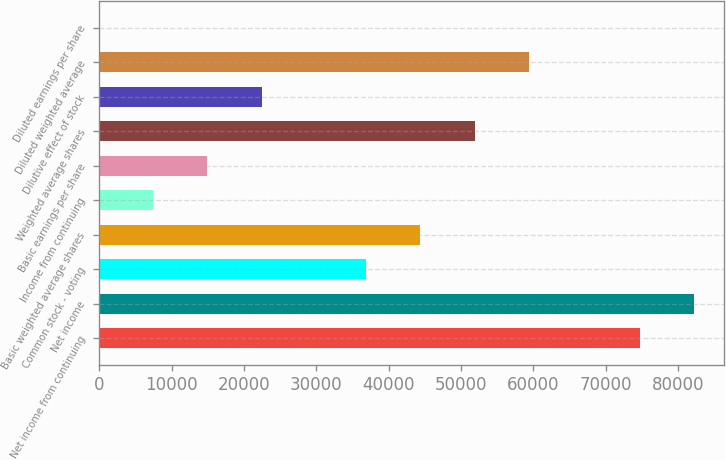Convert chart to OTSL. <chart><loc_0><loc_0><loc_500><loc_500><bar_chart><fcel>Net income from continuing<fcel>Net income<fcel>Common stock - voting<fcel>Basic weighted average shares<fcel>Income from continuing<fcel>Basic earnings per share<fcel>Weighted average shares<fcel>Dilutive effect of stock<fcel>Diluted weighted average<fcel>Diluted earnings per share<nl><fcel>74806<fcel>82286.4<fcel>36930<fcel>44410.4<fcel>7482.37<fcel>14962.8<fcel>51890.8<fcel>22443.2<fcel>59371.2<fcel>1.97<nl></chart> 